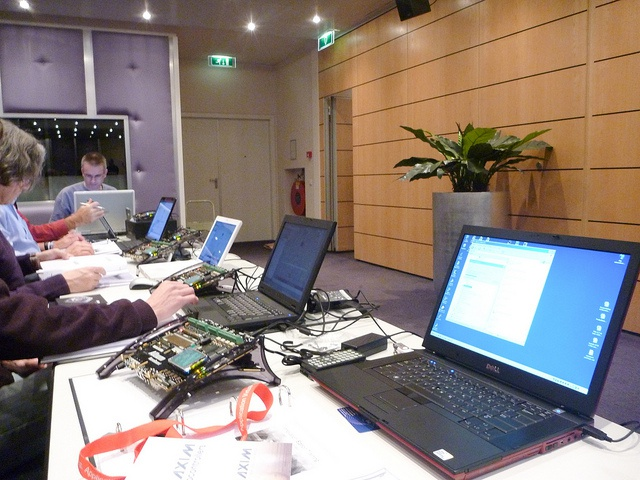Describe the objects in this image and their specific colors. I can see laptop in black, gray, lightblue, white, and navy tones, people in black, gray, and purple tones, potted plant in black, gray, olive, and tan tones, laptop in black, gray, darkblue, and darkgray tones, and laptop in black, white, gray, and darkgray tones in this image. 